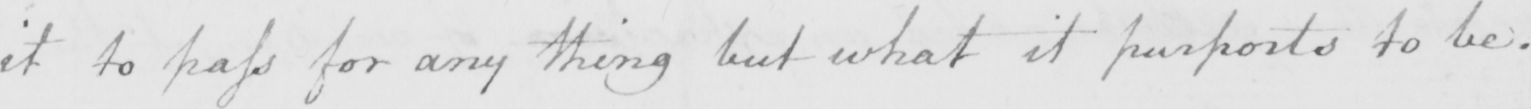Please provide the text content of this handwritten line. it to pass for any thing but what it purports to be . 